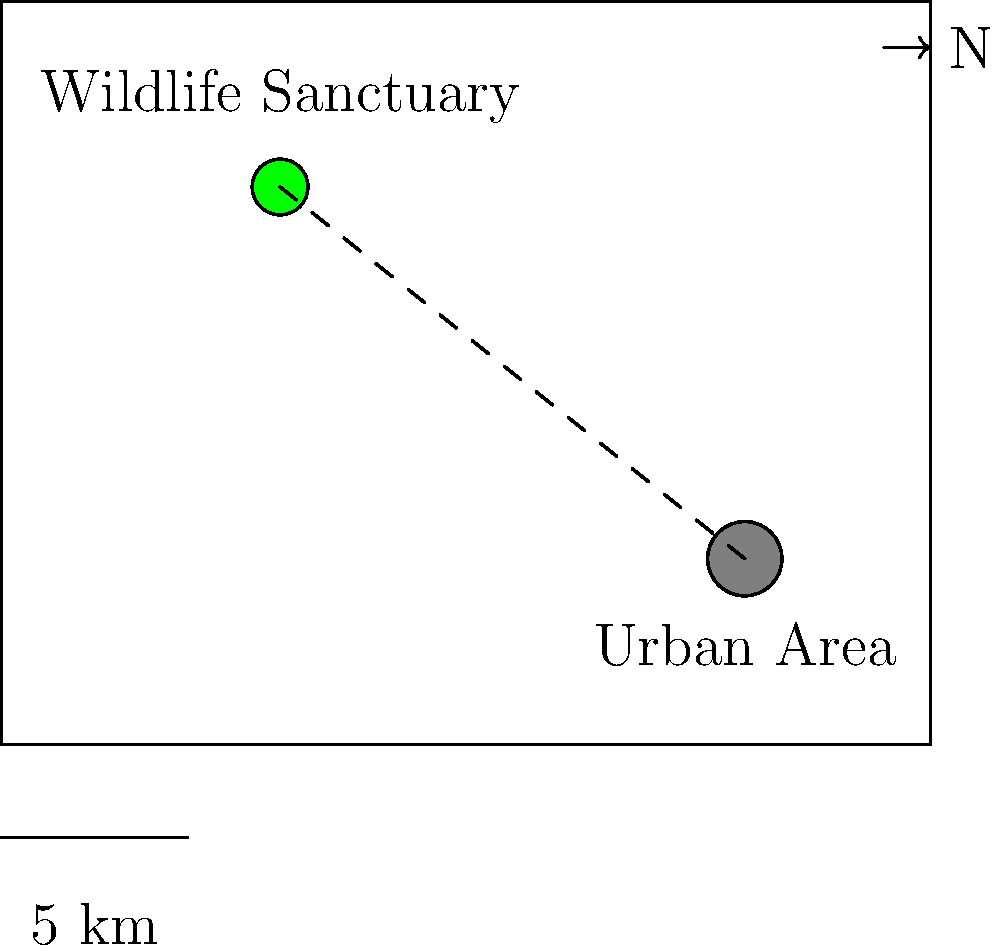Using the scaled map provided, calculate the actual distance between the wildlife sanctuary and the nearby urban area. The scale of the map shows that 2 cm represents 5 km in real distance. To solve this problem, we'll follow these steps:

1. Measure the distance on the map between the wildlife sanctuary and the urban area.
2. Use the given scale to convert this map distance to the actual real-world distance.

Step 1: Measuring the map distance
- On the map, the line between the sanctuary and the urban area is approximately 6.4 cm long.

Step 2: Converting to real-world distance
- The scale shows that 2 cm on the map represents 5 km in real distance.
- We can set up a proportion to find the real distance:
  $$\frac{2 \text{ cm}}{5 \text{ km}} = \frac{6.4 \text{ cm}}{x \text{ km}}$$

- Cross multiply:
  $$2x = 6.4 \times 5$$

- Solve for x:
  $$x = \frac{6.4 \times 5}{2} = 16 \text{ km}$$

Therefore, the actual distance between the wildlife sanctuary and the urban area is 16 km.
Answer: 16 km 